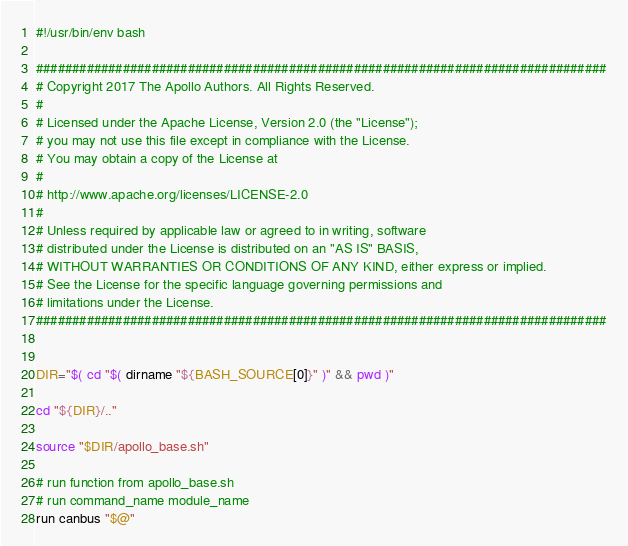Convert code to text. <code><loc_0><loc_0><loc_500><loc_500><_Bash_>#!/usr/bin/env bash

###############################################################################
# Copyright 2017 The Apollo Authors. All Rights Reserved.
#
# Licensed under the Apache License, Version 2.0 (the "License");
# you may not use this file except in compliance with the License.
# You may obtain a copy of the License at
#
# http://www.apache.org/licenses/LICENSE-2.0
#
# Unless required by applicable law or agreed to in writing, software
# distributed under the License is distributed on an "AS IS" BASIS,
# WITHOUT WARRANTIES OR CONDITIONS OF ANY KIND, either express or implied.
# See the License for the specific language governing permissions and
# limitations under the License.
###############################################################################


DIR="$( cd "$( dirname "${BASH_SOURCE[0]}" )" && pwd )"

cd "${DIR}/.."

source "$DIR/apollo_base.sh"

# run function from apollo_base.sh
# run command_name module_name
run canbus "$@"
</code> 